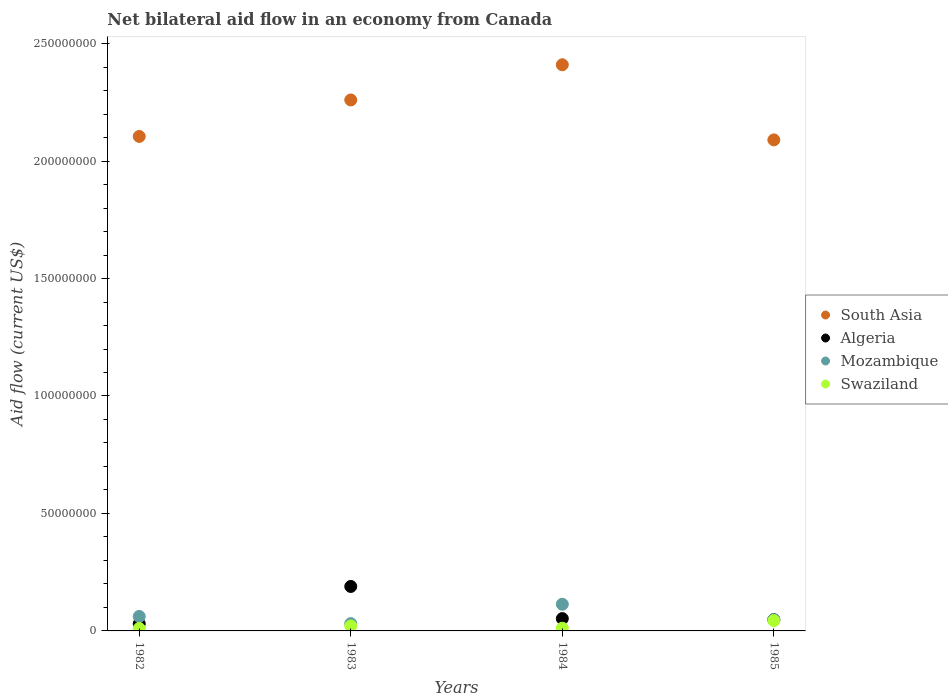What is the net bilateral aid flow in Algeria in 1982?
Your answer should be compact. 3.04e+06. Across all years, what is the maximum net bilateral aid flow in Swaziland?
Your answer should be very brief. 4.39e+06. Across all years, what is the minimum net bilateral aid flow in Mozambique?
Make the answer very short. 3.10e+06. In which year was the net bilateral aid flow in Swaziland maximum?
Provide a short and direct response. 1985. In which year was the net bilateral aid flow in Swaziland minimum?
Keep it short and to the point. 1982. What is the total net bilateral aid flow in South Asia in the graph?
Provide a succinct answer. 8.86e+08. What is the difference between the net bilateral aid flow in Mozambique in 1982 and that in 1985?
Your answer should be very brief. 1.39e+06. What is the difference between the net bilateral aid flow in Mozambique in 1985 and the net bilateral aid flow in Swaziland in 1984?
Your answer should be very brief. 3.61e+06. What is the average net bilateral aid flow in South Asia per year?
Ensure brevity in your answer.  2.22e+08. In the year 1983, what is the difference between the net bilateral aid flow in Swaziland and net bilateral aid flow in South Asia?
Give a very brief answer. -2.24e+08. What is the ratio of the net bilateral aid flow in Swaziland in 1982 to that in 1983?
Keep it short and to the point. 0.5. What is the difference between the highest and the second highest net bilateral aid flow in South Asia?
Keep it short and to the point. 1.50e+07. What is the difference between the highest and the lowest net bilateral aid flow in South Asia?
Provide a short and direct response. 3.20e+07. In how many years, is the net bilateral aid flow in Algeria greater than the average net bilateral aid flow in Algeria taken over all years?
Make the answer very short. 1. Is it the case that in every year, the sum of the net bilateral aid flow in South Asia and net bilateral aid flow in Mozambique  is greater than the sum of net bilateral aid flow in Algeria and net bilateral aid flow in Swaziland?
Offer a very short reply. No. Is it the case that in every year, the sum of the net bilateral aid flow in Swaziland and net bilateral aid flow in Mozambique  is greater than the net bilateral aid flow in South Asia?
Make the answer very short. No. Does the net bilateral aid flow in Algeria monotonically increase over the years?
Your answer should be very brief. No. Is the net bilateral aid flow in Swaziland strictly greater than the net bilateral aid flow in Mozambique over the years?
Provide a short and direct response. No. Is the net bilateral aid flow in Mozambique strictly less than the net bilateral aid flow in South Asia over the years?
Your answer should be compact. Yes. How many dotlines are there?
Ensure brevity in your answer.  4. What is the difference between two consecutive major ticks on the Y-axis?
Make the answer very short. 5.00e+07. Are the values on the major ticks of Y-axis written in scientific E-notation?
Your answer should be compact. No. Does the graph contain any zero values?
Provide a succinct answer. No. Does the graph contain grids?
Provide a short and direct response. No. What is the title of the graph?
Your response must be concise. Net bilateral aid flow in an economy from Canada. What is the label or title of the X-axis?
Your response must be concise. Years. What is the label or title of the Y-axis?
Provide a short and direct response. Aid flow (current US$). What is the Aid flow (current US$) in South Asia in 1982?
Offer a terse response. 2.10e+08. What is the Aid flow (current US$) in Algeria in 1982?
Offer a very short reply. 3.04e+06. What is the Aid flow (current US$) of Mozambique in 1982?
Ensure brevity in your answer.  6.16e+06. What is the Aid flow (current US$) in Swaziland in 1982?
Your answer should be very brief. 1.04e+06. What is the Aid flow (current US$) of South Asia in 1983?
Ensure brevity in your answer.  2.26e+08. What is the Aid flow (current US$) in Algeria in 1983?
Your answer should be compact. 1.89e+07. What is the Aid flow (current US$) in Mozambique in 1983?
Give a very brief answer. 3.10e+06. What is the Aid flow (current US$) of Swaziland in 1983?
Provide a short and direct response. 2.10e+06. What is the Aid flow (current US$) in South Asia in 1984?
Offer a very short reply. 2.41e+08. What is the Aid flow (current US$) in Algeria in 1984?
Keep it short and to the point. 5.25e+06. What is the Aid flow (current US$) of Mozambique in 1984?
Your answer should be compact. 1.14e+07. What is the Aid flow (current US$) of Swaziland in 1984?
Provide a succinct answer. 1.16e+06. What is the Aid flow (current US$) in South Asia in 1985?
Offer a very short reply. 2.09e+08. What is the Aid flow (current US$) of Algeria in 1985?
Offer a very short reply. 4.78e+06. What is the Aid flow (current US$) in Mozambique in 1985?
Your answer should be very brief. 4.77e+06. What is the Aid flow (current US$) of Swaziland in 1985?
Provide a succinct answer. 4.39e+06. Across all years, what is the maximum Aid flow (current US$) in South Asia?
Offer a terse response. 2.41e+08. Across all years, what is the maximum Aid flow (current US$) of Algeria?
Provide a succinct answer. 1.89e+07. Across all years, what is the maximum Aid flow (current US$) of Mozambique?
Make the answer very short. 1.14e+07. Across all years, what is the maximum Aid flow (current US$) in Swaziland?
Make the answer very short. 4.39e+06. Across all years, what is the minimum Aid flow (current US$) of South Asia?
Provide a succinct answer. 2.09e+08. Across all years, what is the minimum Aid flow (current US$) of Algeria?
Ensure brevity in your answer.  3.04e+06. Across all years, what is the minimum Aid flow (current US$) of Mozambique?
Make the answer very short. 3.10e+06. Across all years, what is the minimum Aid flow (current US$) in Swaziland?
Your answer should be compact. 1.04e+06. What is the total Aid flow (current US$) in South Asia in the graph?
Your answer should be very brief. 8.86e+08. What is the total Aid flow (current US$) in Algeria in the graph?
Your response must be concise. 3.20e+07. What is the total Aid flow (current US$) in Mozambique in the graph?
Keep it short and to the point. 2.54e+07. What is the total Aid flow (current US$) of Swaziland in the graph?
Ensure brevity in your answer.  8.69e+06. What is the difference between the Aid flow (current US$) in South Asia in 1982 and that in 1983?
Provide a succinct answer. -1.55e+07. What is the difference between the Aid flow (current US$) in Algeria in 1982 and that in 1983?
Offer a very short reply. -1.59e+07. What is the difference between the Aid flow (current US$) in Mozambique in 1982 and that in 1983?
Make the answer very short. 3.06e+06. What is the difference between the Aid flow (current US$) of Swaziland in 1982 and that in 1983?
Offer a very short reply. -1.06e+06. What is the difference between the Aid flow (current US$) in South Asia in 1982 and that in 1984?
Provide a short and direct response. -3.05e+07. What is the difference between the Aid flow (current US$) in Algeria in 1982 and that in 1984?
Offer a terse response. -2.21e+06. What is the difference between the Aid flow (current US$) of Mozambique in 1982 and that in 1984?
Make the answer very short. -5.19e+06. What is the difference between the Aid flow (current US$) in Swaziland in 1982 and that in 1984?
Make the answer very short. -1.20e+05. What is the difference between the Aid flow (current US$) in South Asia in 1982 and that in 1985?
Make the answer very short. 1.47e+06. What is the difference between the Aid flow (current US$) of Algeria in 1982 and that in 1985?
Make the answer very short. -1.74e+06. What is the difference between the Aid flow (current US$) in Mozambique in 1982 and that in 1985?
Ensure brevity in your answer.  1.39e+06. What is the difference between the Aid flow (current US$) of Swaziland in 1982 and that in 1985?
Give a very brief answer. -3.35e+06. What is the difference between the Aid flow (current US$) in South Asia in 1983 and that in 1984?
Ensure brevity in your answer.  -1.50e+07. What is the difference between the Aid flow (current US$) of Algeria in 1983 and that in 1984?
Your answer should be very brief. 1.37e+07. What is the difference between the Aid flow (current US$) of Mozambique in 1983 and that in 1984?
Provide a short and direct response. -8.25e+06. What is the difference between the Aid flow (current US$) in Swaziland in 1983 and that in 1984?
Your answer should be very brief. 9.40e+05. What is the difference between the Aid flow (current US$) in South Asia in 1983 and that in 1985?
Provide a short and direct response. 1.70e+07. What is the difference between the Aid flow (current US$) in Algeria in 1983 and that in 1985?
Your response must be concise. 1.42e+07. What is the difference between the Aid flow (current US$) in Mozambique in 1983 and that in 1985?
Your response must be concise. -1.67e+06. What is the difference between the Aid flow (current US$) in Swaziland in 1983 and that in 1985?
Offer a very short reply. -2.29e+06. What is the difference between the Aid flow (current US$) in South Asia in 1984 and that in 1985?
Ensure brevity in your answer.  3.20e+07. What is the difference between the Aid flow (current US$) of Mozambique in 1984 and that in 1985?
Offer a very short reply. 6.58e+06. What is the difference between the Aid flow (current US$) of Swaziland in 1984 and that in 1985?
Ensure brevity in your answer.  -3.23e+06. What is the difference between the Aid flow (current US$) of South Asia in 1982 and the Aid flow (current US$) of Algeria in 1983?
Your answer should be compact. 1.92e+08. What is the difference between the Aid flow (current US$) in South Asia in 1982 and the Aid flow (current US$) in Mozambique in 1983?
Offer a very short reply. 2.07e+08. What is the difference between the Aid flow (current US$) in South Asia in 1982 and the Aid flow (current US$) in Swaziland in 1983?
Your response must be concise. 2.08e+08. What is the difference between the Aid flow (current US$) of Algeria in 1982 and the Aid flow (current US$) of Mozambique in 1983?
Make the answer very short. -6.00e+04. What is the difference between the Aid flow (current US$) in Algeria in 1982 and the Aid flow (current US$) in Swaziland in 1983?
Your answer should be compact. 9.40e+05. What is the difference between the Aid flow (current US$) in Mozambique in 1982 and the Aid flow (current US$) in Swaziland in 1983?
Give a very brief answer. 4.06e+06. What is the difference between the Aid flow (current US$) of South Asia in 1982 and the Aid flow (current US$) of Algeria in 1984?
Keep it short and to the point. 2.05e+08. What is the difference between the Aid flow (current US$) of South Asia in 1982 and the Aid flow (current US$) of Mozambique in 1984?
Make the answer very short. 1.99e+08. What is the difference between the Aid flow (current US$) of South Asia in 1982 and the Aid flow (current US$) of Swaziland in 1984?
Give a very brief answer. 2.09e+08. What is the difference between the Aid flow (current US$) of Algeria in 1982 and the Aid flow (current US$) of Mozambique in 1984?
Offer a terse response. -8.31e+06. What is the difference between the Aid flow (current US$) in Algeria in 1982 and the Aid flow (current US$) in Swaziland in 1984?
Your answer should be compact. 1.88e+06. What is the difference between the Aid flow (current US$) in Mozambique in 1982 and the Aid flow (current US$) in Swaziland in 1984?
Give a very brief answer. 5.00e+06. What is the difference between the Aid flow (current US$) of South Asia in 1982 and the Aid flow (current US$) of Algeria in 1985?
Your response must be concise. 2.06e+08. What is the difference between the Aid flow (current US$) in South Asia in 1982 and the Aid flow (current US$) in Mozambique in 1985?
Offer a terse response. 2.06e+08. What is the difference between the Aid flow (current US$) in South Asia in 1982 and the Aid flow (current US$) in Swaziland in 1985?
Offer a terse response. 2.06e+08. What is the difference between the Aid flow (current US$) in Algeria in 1982 and the Aid flow (current US$) in Mozambique in 1985?
Provide a short and direct response. -1.73e+06. What is the difference between the Aid flow (current US$) of Algeria in 1982 and the Aid flow (current US$) of Swaziland in 1985?
Your answer should be very brief. -1.35e+06. What is the difference between the Aid flow (current US$) of Mozambique in 1982 and the Aid flow (current US$) of Swaziland in 1985?
Give a very brief answer. 1.77e+06. What is the difference between the Aid flow (current US$) of South Asia in 1983 and the Aid flow (current US$) of Algeria in 1984?
Offer a terse response. 2.21e+08. What is the difference between the Aid flow (current US$) of South Asia in 1983 and the Aid flow (current US$) of Mozambique in 1984?
Offer a terse response. 2.15e+08. What is the difference between the Aid flow (current US$) of South Asia in 1983 and the Aid flow (current US$) of Swaziland in 1984?
Ensure brevity in your answer.  2.25e+08. What is the difference between the Aid flow (current US$) of Algeria in 1983 and the Aid flow (current US$) of Mozambique in 1984?
Keep it short and to the point. 7.58e+06. What is the difference between the Aid flow (current US$) in Algeria in 1983 and the Aid flow (current US$) in Swaziland in 1984?
Offer a very short reply. 1.78e+07. What is the difference between the Aid flow (current US$) of Mozambique in 1983 and the Aid flow (current US$) of Swaziland in 1984?
Your answer should be very brief. 1.94e+06. What is the difference between the Aid flow (current US$) in South Asia in 1983 and the Aid flow (current US$) in Algeria in 1985?
Provide a short and direct response. 2.21e+08. What is the difference between the Aid flow (current US$) in South Asia in 1983 and the Aid flow (current US$) in Mozambique in 1985?
Give a very brief answer. 2.21e+08. What is the difference between the Aid flow (current US$) of South Asia in 1983 and the Aid flow (current US$) of Swaziland in 1985?
Provide a short and direct response. 2.22e+08. What is the difference between the Aid flow (current US$) in Algeria in 1983 and the Aid flow (current US$) in Mozambique in 1985?
Your response must be concise. 1.42e+07. What is the difference between the Aid flow (current US$) of Algeria in 1983 and the Aid flow (current US$) of Swaziland in 1985?
Offer a very short reply. 1.45e+07. What is the difference between the Aid flow (current US$) of Mozambique in 1983 and the Aid flow (current US$) of Swaziland in 1985?
Offer a very short reply. -1.29e+06. What is the difference between the Aid flow (current US$) of South Asia in 1984 and the Aid flow (current US$) of Algeria in 1985?
Make the answer very short. 2.36e+08. What is the difference between the Aid flow (current US$) in South Asia in 1984 and the Aid flow (current US$) in Mozambique in 1985?
Your answer should be compact. 2.36e+08. What is the difference between the Aid flow (current US$) in South Asia in 1984 and the Aid flow (current US$) in Swaziland in 1985?
Your answer should be very brief. 2.37e+08. What is the difference between the Aid flow (current US$) in Algeria in 1984 and the Aid flow (current US$) in Mozambique in 1985?
Give a very brief answer. 4.80e+05. What is the difference between the Aid flow (current US$) in Algeria in 1984 and the Aid flow (current US$) in Swaziland in 1985?
Offer a terse response. 8.60e+05. What is the difference between the Aid flow (current US$) of Mozambique in 1984 and the Aid flow (current US$) of Swaziland in 1985?
Your answer should be compact. 6.96e+06. What is the average Aid flow (current US$) of South Asia per year?
Your answer should be compact. 2.22e+08. What is the average Aid flow (current US$) of Mozambique per year?
Offer a terse response. 6.34e+06. What is the average Aid flow (current US$) in Swaziland per year?
Your answer should be compact. 2.17e+06. In the year 1982, what is the difference between the Aid flow (current US$) in South Asia and Aid flow (current US$) in Algeria?
Your response must be concise. 2.07e+08. In the year 1982, what is the difference between the Aid flow (current US$) of South Asia and Aid flow (current US$) of Mozambique?
Your response must be concise. 2.04e+08. In the year 1982, what is the difference between the Aid flow (current US$) of South Asia and Aid flow (current US$) of Swaziland?
Your response must be concise. 2.09e+08. In the year 1982, what is the difference between the Aid flow (current US$) in Algeria and Aid flow (current US$) in Mozambique?
Your answer should be very brief. -3.12e+06. In the year 1982, what is the difference between the Aid flow (current US$) of Mozambique and Aid flow (current US$) of Swaziland?
Provide a short and direct response. 5.12e+06. In the year 1983, what is the difference between the Aid flow (current US$) in South Asia and Aid flow (current US$) in Algeria?
Provide a succinct answer. 2.07e+08. In the year 1983, what is the difference between the Aid flow (current US$) in South Asia and Aid flow (current US$) in Mozambique?
Your answer should be compact. 2.23e+08. In the year 1983, what is the difference between the Aid flow (current US$) of South Asia and Aid flow (current US$) of Swaziland?
Offer a very short reply. 2.24e+08. In the year 1983, what is the difference between the Aid flow (current US$) in Algeria and Aid flow (current US$) in Mozambique?
Your response must be concise. 1.58e+07. In the year 1983, what is the difference between the Aid flow (current US$) of Algeria and Aid flow (current US$) of Swaziland?
Keep it short and to the point. 1.68e+07. In the year 1983, what is the difference between the Aid flow (current US$) of Mozambique and Aid flow (current US$) of Swaziland?
Your answer should be compact. 1.00e+06. In the year 1984, what is the difference between the Aid flow (current US$) of South Asia and Aid flow (current US$) of Algeria?
Your response must be concise. 2.36e+08. In the year 1984, what is the difference between the Aid flow (current US$) of South Asia and Aid flow (current US$) of Mozambique?
Ensure brevity in your answer.  2.30e+08. In the year 1984, what is the difference between the Aid flow (current US$) in South Asia and Aid flow (current US$) in Swaziland?
Offer a terse response. 2.40e+08. In the year 1984, what is the difference between the Aid flow (current US$) of Algeria and Aid flow (current US$) of Mozambique?
Offer a very short reply. -6.10e+06. In the year 1984, what is the difference between the Aid flow (current US$) of Algeria and Aid flow (current US$) of Swaziland?
Give a very brief answer. 4.09e+06. In the year 1984, what is the difference between the Aid flow (current US$) in Mozambique and Aid flow (current US$) in Swaziland?
Make the answer very short. 1.02e+07. In the year 1985, what is the difference between the Aid flow (current US$) of South Asia and Aid flow (current US$) of Algeria?
Make the answer very short. 2.04e+08. In the year 1985, what is the difference between the Aid flow (current US$) in South Asia and Aid flow (current US$) in Mozambique?
Your response must be concise. 2.04e+08. In the year 1985, what is the difference between the Aid flow (current US$) of South Asia and Aid flow (current US$) of Swaziland?
Keep it short and to the point. 2.05e+08. In the year 1985, what is the difference between the Aid flow (current US$) in Algeria and Aid flow (current US$) in Mozambique?
Give a very brief answer. 10000. What is the ratio of the Aid flow (current US$) of South Asia in 1982 to that in 1983?
Your answer should be compact. 0.93. What is the ratio of the Aid flow (current US$) in Algeria in 1982 to that in 1983?
Ensure brevity in your answer.  0.16. What is the ratio of the Aid flow (current US$) in Mozambique in 1982 to that in 1983?
Keep it short and to the point. 1.99. What is the ratio of the Aid flow (current US$) of Swaziland in 1982 to that in 1983?
Provide a succinct answer. 0.5. What is the ratio of the Aid flow (current US$) in South Asia in 1982 to that in 1984?
Give a very brief answer. 0.87. What is the ratio of the Aid flow (current US$) in Algeria in 1982 to that in 1984?
Provide a short and direct response. 0.58. What is the ratio of the Aid flow (current US$) in Mozambique in 1982 to that in 1984?
Offer a very short reply. 0.54. What is the ratio of the Aid flow (current US$) of Swaziland in 1982 to that in 1984?
Offer a terse response. 0.9. What is the ratio of the Aid flow (current US$) of South Asia in 1982 to that in 1985?
Make the answer very short. 1.01. What is the ratio of the Aid flow (current US$) in Algeria in 1982 to that in 1985?
Your answer should be compact. 0.64. What is the ratio of the Aid flow (current US$) in Mozambique in 1982 to that in 1985?
Keep it short and to the point. 1.29. What is the ratio of the Aid flow (current US$) in Swaziland in 1982 to that in 1985?
Provide a succinct answer. 0.24. What is the ratio of the Aid flow (current US$) of South Asia in 1983 to that in 1984?
Offer a terse response. 0.94. What is the ratio of the Aid flow (current US$) in Algeria in 1983 to that in 1984?
Your answer should be compact. 3.61. What is the ratio of the Aid flow (current US$) in Mozambique in 1983 to that in 1984?
Keep it short and to the point. 0.27. What is the ratio of the Aid flow (current US$) of Swaziland in 1983 to that in 1984?
Your answer should be compact. 1.81. What is the ratio of the Aid flow (current US$) of South Asia in 1983 to that in 1985?
Offer a very short reply. 1.08. What is the ratio of the Aid flow (current US$) in Algeria in 1983 to that in 1985?
Give a very brief answer. 3.96. What is the ratio of the Aid flow (current US$) in Mozambique in 1983 to that in 1985?
Ensure brevity in your answer.  0.65. What is the ratio of the Aid flow (current US$) of Swaziland in 1983 to that in 1985?
Offer a terse response. 0.48. What is the ratio of the Aid flow (current US$) of South Asia in 1984 to that in 1985?
Make the answer very short. 1.15. What is the ratio of the Aid flow (current US$) of Algeria in 1984 to that in 1985?
Make the answer very short. 1.1. What is the ratio of the Aid flow (current US$) of Mozambique in 1984 to that in 1985?
Ensure brevity in your answer.  2.38. What is the ratio of the Aid flow (current US$) of Swaziland in 1984 to that in 1985?
Offer a terse response. 0.26. What is the difference between the highest and the second highest Aid flow (current US$) of South Asia?
Give a very brief answer. 1.50e+07. What is the difference between the highest and the second highest Aid flow (current US$) of Algeria?
Your answer should be very brief. 1.37e+07. What is the difference between the highest and the second highest Aid flow (current US$) in Mozambique?
Make the answer very short. 5.19e+06. What is the difference between the highest and the second highest Aid flow (current US$) of Swaziland?
Give a very brief answer. 2.29e+06. What is the difference between the highest and the lowest Aid flow (current US$) of South Asia?
Offer a terse response. 3.20e+07. What is the difference between the highest and the lowest Aid flow (current US$) in Algeria?
Keep it short and to the point. 1.59e+07. What is the difference between the highest and the lowest Aid flow (current US$) in Mozambique?
Your answer should be compact. 8.25e+06. What is the difference between the highest and the lowest Aid flow (current US$) in Swaziland?
Your answer should be compact. 3.35e+06. 